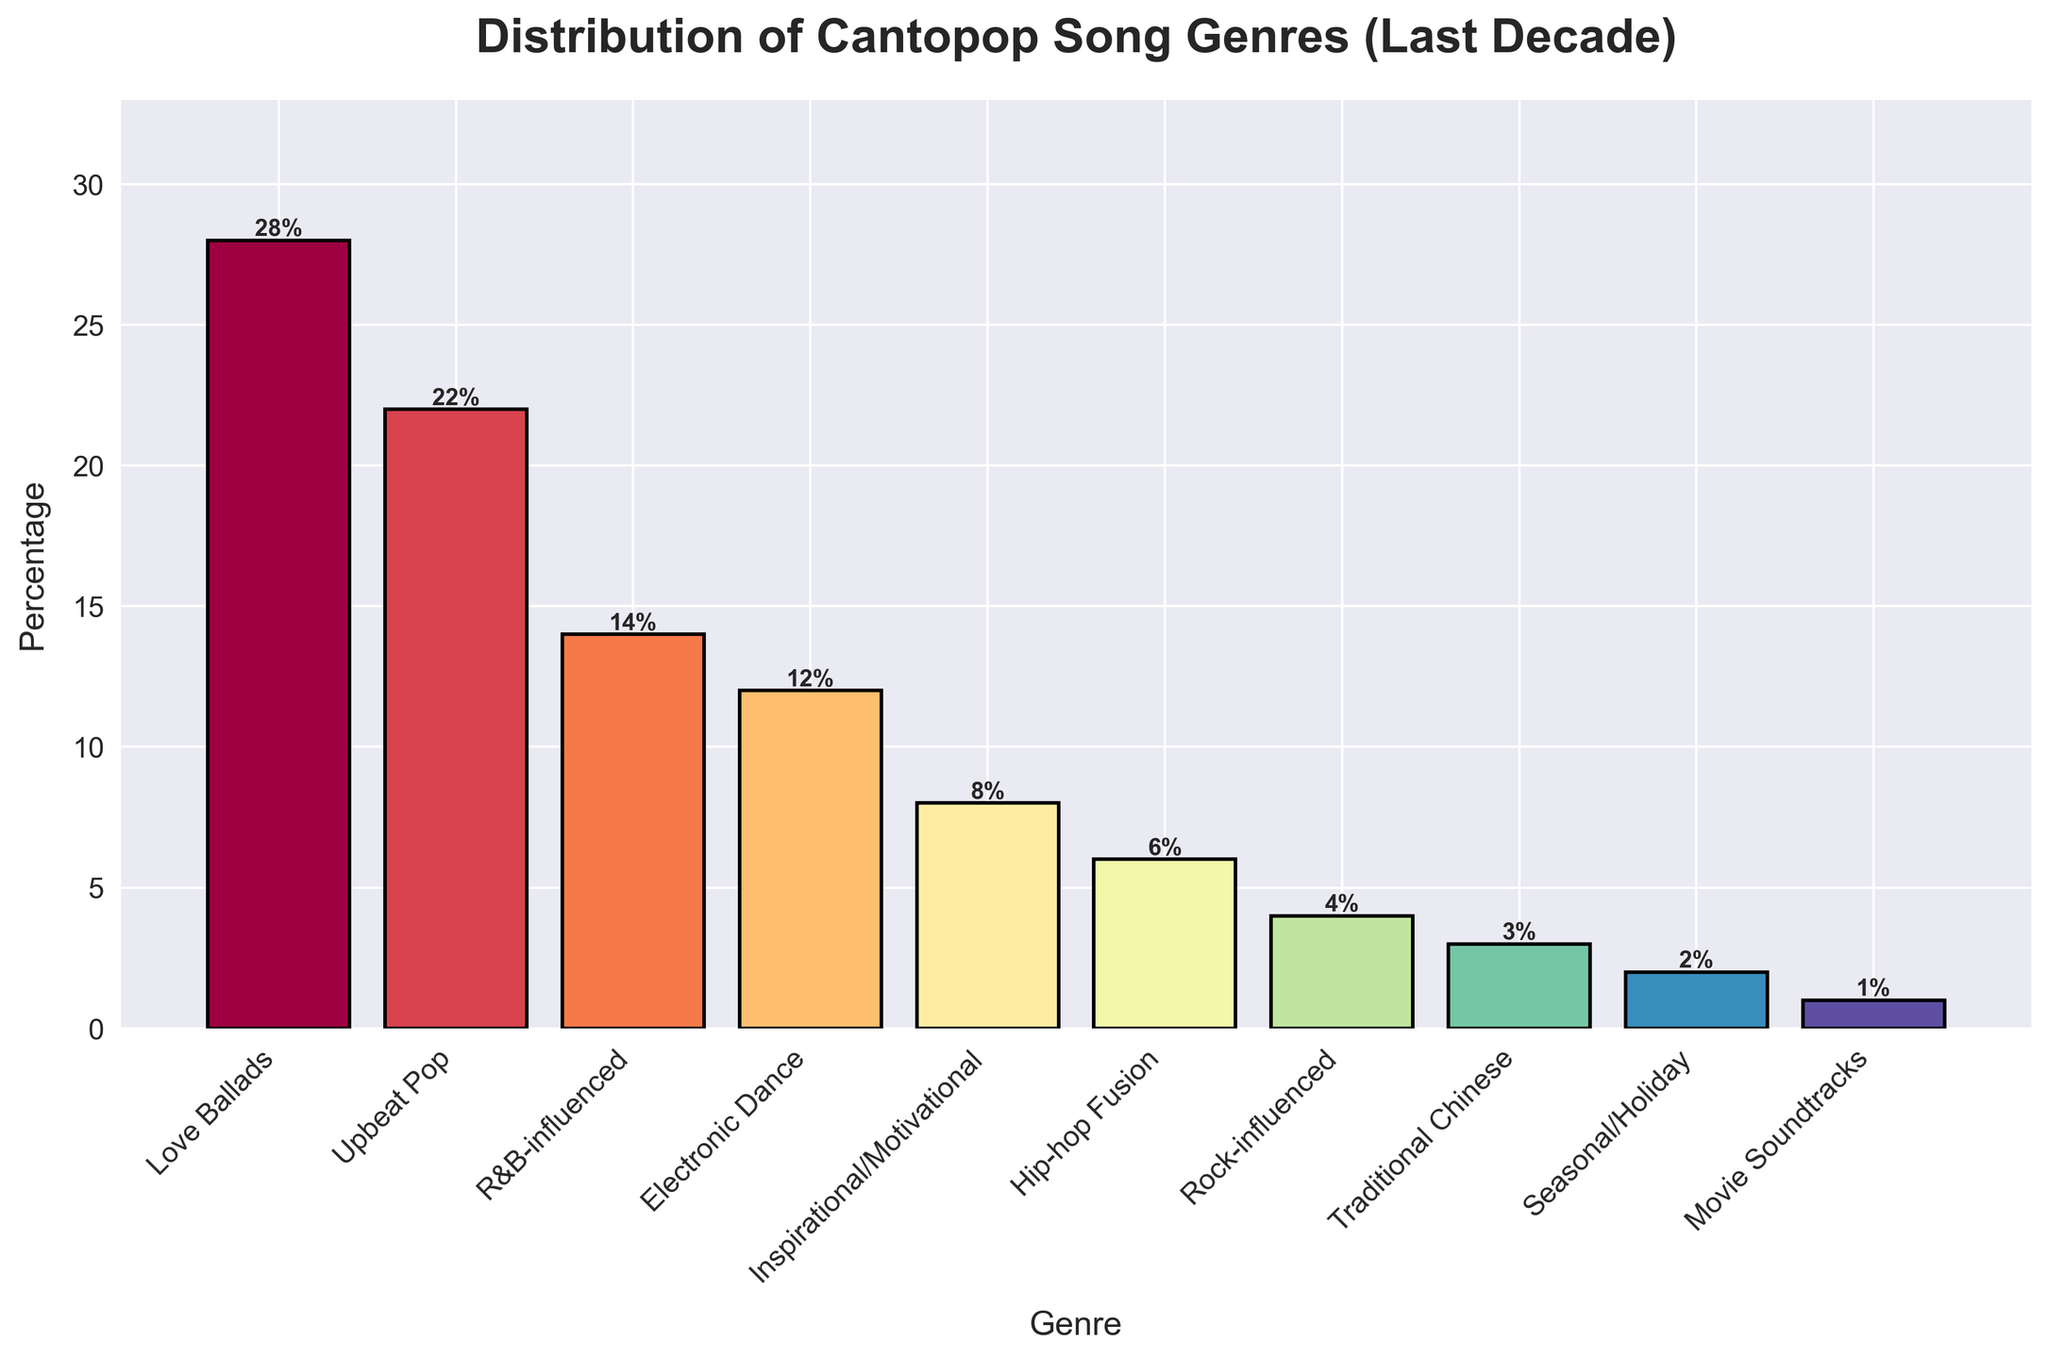What is the most popular genre of Cantopop songs released in the last decade? The bar representing 'Love Ballads' has the highest percentage at 28%. This is the tallest bar in the chart.
Answer: Love Ballads What is the total percentage of genres that have a percentage lower than 5%? Adding up the percentages of 'Rock-influenced' (4%), 'Traditional Chinese' (3%), 'Seasonal/Holiday' (2%), and 'Movie Soundtracks' (1%): 4% + 3% + 2% + 1% = 10%
Answer: 10% How does the percentage of 'Electronic Dance' compare to 'Hip-hop Fusion'? The 'Electronic Dance' genre has a percentage of 12%, while 'Hip-hop Fusion' has a percentage of 6%. So, 'Electronic Dance' is higher than 'Hip-hop Fusion' by 12% - 6% = 6%.
Answer: 6% higher Which genre has the second-lowest percentage, and what is it? The second-lowest bar after 'Movie Soundtracks' (1%) is the 'Seasonal/Holiday' bar, which is at 2%.
Answer: Seasonal/Holiday, 2% What is the combined percentage of 'Upbeat Pop' and 'R&B-influenced'? Adding the percentages of 'Upbeat Pop' (22%) and 'R&B-influenced' (14%): 22% + 14% = 36%.
Answer: 36% How many genres have a percentage greater than 10%? The genres with percentages greater than 10% are 'Love Ballads' (28%), 'Upbeat Pop' (22%), 'R&B-influenced' (14%), and 'Electronic Dance' (12%). There are 4 genres.
Answer: 4 What is the difference between the highest and the lowest percentages shown in the bar chart? Subtract the lowest percentage 'Movie Soundtracks' (1%) from the highest percentage 'Love Ballads' (28%): 28% - 1% = 27%.
Answer: 27% What is the approximate average percentage of the 'Love Ballads', 'Upbeat Pop', and 'R&B-influenced' genres? Adding the percentages of 'Love Ballads' (28%), 'Upbeat Pop' (22%), and 'R&B-influenced' (14%) and then dividing by the number of genres (3): (28% + 22% + 14%) / 3 ≈ 21.33%.
Answer: 21.33% 